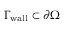Convert formula to latex. <formula><loc_0><loc_0><loc_500><loc_500>\Gamma _ { w a l l } \subset \partial \Omega</formula> 